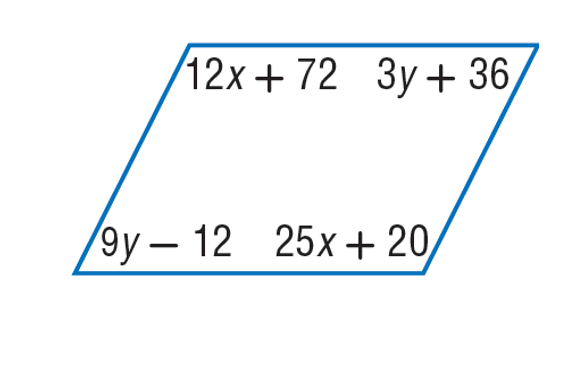Answer the mathemtical geometry problem and directly provide the correct option letter.
Question: Find y so that the quadrilateral is a parallelogram.
Choices: A: 8 B: 9 C: 25 D: 96 A 